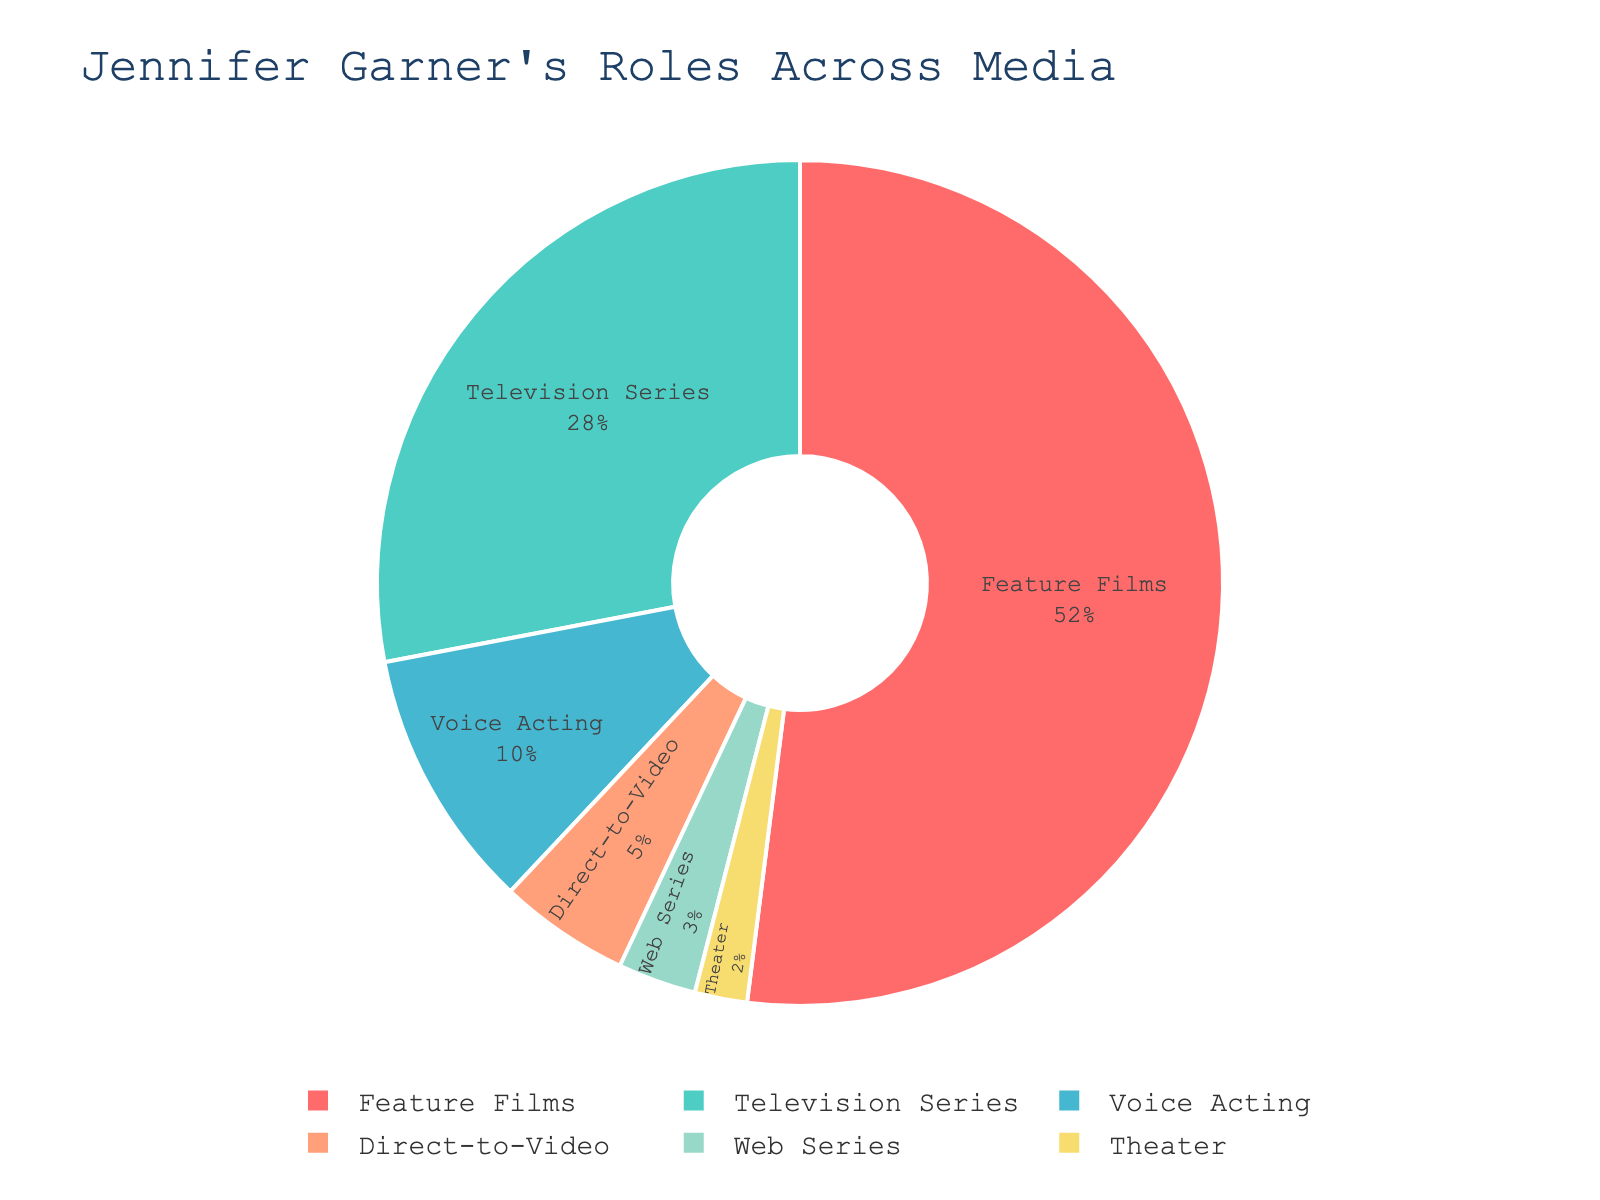What percentage of Jennifer Garner's roles has been in feature films? The figure shows the percentage breakdown of Jennifer Garner's roles across different media. We just need to look at the part labeled "Feature Films."
Answer: 52% Which media type has the smallest percentage of Jennifer Garner's roles? By identifying the segment with the smallest percentage in the pie chart, we can find the answer.
Answer: Theater What is the combined percentage of Jennifer Garner's roles in television series and web series? The chart shows that Television Series is 28% and Web Series is 3%. Adding these together gives 28% + 3% = 31%.
Answer: 31% Jennifer Garner has done voice acting and direct-to-video roles. What is the total percentage of these two media types? Voice Acting is 10% and Direct-to-Video is 5%, so their total percentage is 10% + 5% = 15%.
Answer: 15% How much greater is the percentage of Jennifer Garner's roles in feature films compared to television series? Feature Films are 52% and Television Series are 28%. The difference is 52% - 28% = 24%.
Answer: 24% Between direct-to-video and web series, which media type has a larger percentage of Jennifer Garner's roles and by how much? Direct-to-Video is 5% and Web Series is 3%. The difference is 5% - 3% = 2%.
Answer: Direct-to-Video by 2% What fraction of Jennifer Garner's roles have been either in voice acting or theater roles? Voice Acting is 10% and Theater is 2%. Adding them, 10% + 2% = 12%. As a fraction out of 100%, it is 12/100 = 0.12
Answer: 0.12 If Jennifer Garner's roles in feature films doubled and were added to her theater roles, what would the new percentage for feature films be? If feature film roles doubled, the percentage would be 52% * 2 = 104%. Adding her theater roles, 104% + 2% = 106%. However, percentages are relative measurements and cannot exceed 100%.
Answer: N/A - percentages cannot exceed 100% Which three media types constitute exactly 90% of Jennifer Garner's roles? By observing the pie chart and summing up the percentages, the three media with the largest percentages that add up to 90% are: Feature Films (52%), Television Series (28%), and Voice Acting (10%). 52% + 28% + 10% = 90%.
Answer: Feature Films, Television Series, Voice Acting 